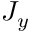Convert formula to latex. <formula><loc_0><loc_0><loc_500><loc_500>J _ { y }</formula> 